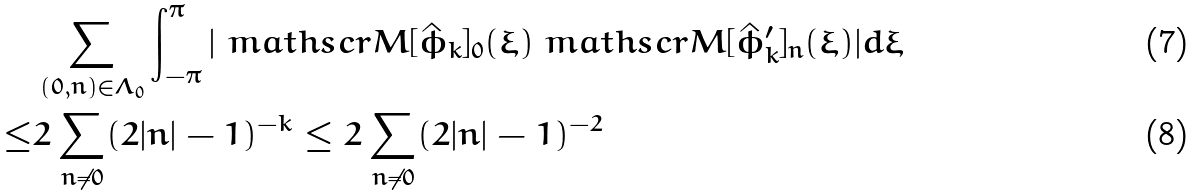<formula> <loc_0><loc_0><loc_500><loc_500>& \sum _ { ( 0 , n ) \in \Lambda _ { 0 } } \int _ { - \pi } ^ { \pi } | \ m a t h s c r { M } [ \hat { \phi } _ { k } ] _ { 0 } ( \xi ) \ m a t h s c r { M } [ \hat { \phi } ^ { \prime } _ { k } ] _ { n } ( \xi ) | d \xi \\ \leq & 2 \sum _ { n \neq 0 } ( 2 | n | - 1 ) ^ { - k } \leq 2 \sum _ { n \neq 0 } ( 2 | n | - 1 ) ^ { - 2 }</formula> 